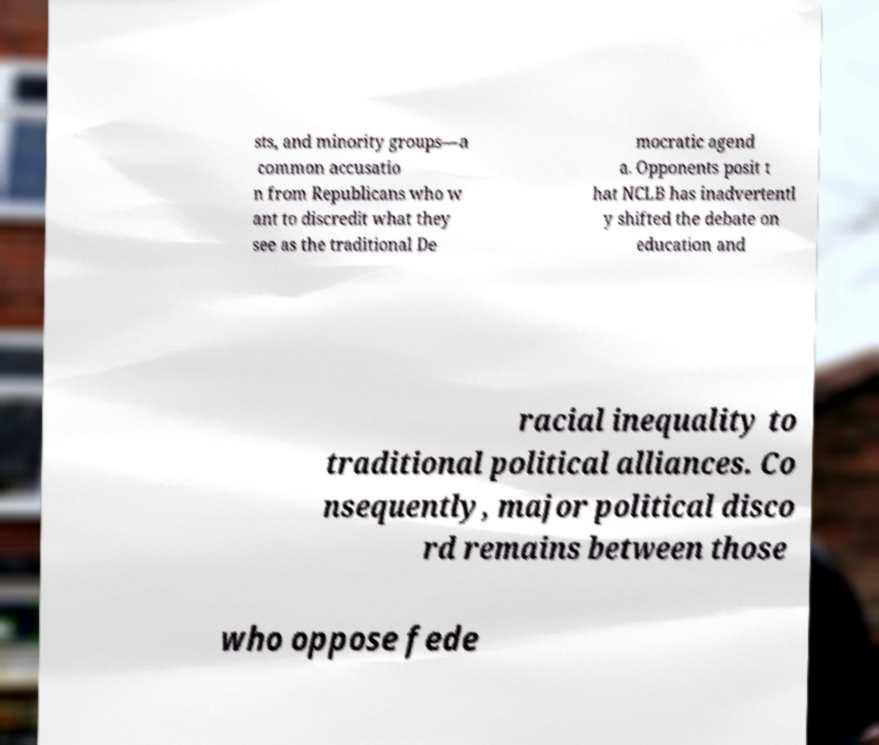Please identify and transcribe the text found in this image. sts, and minority groups—a common accusatio n from Republicans who w ant to discredit what they see as the traditional De mocratic agend a. Opponents posit t hat NCLB has inadvertentl y shifted the debate on education and racial inequality to traditional political alliances. Co nsequently, major political disco rd remains between those who oppose fede 